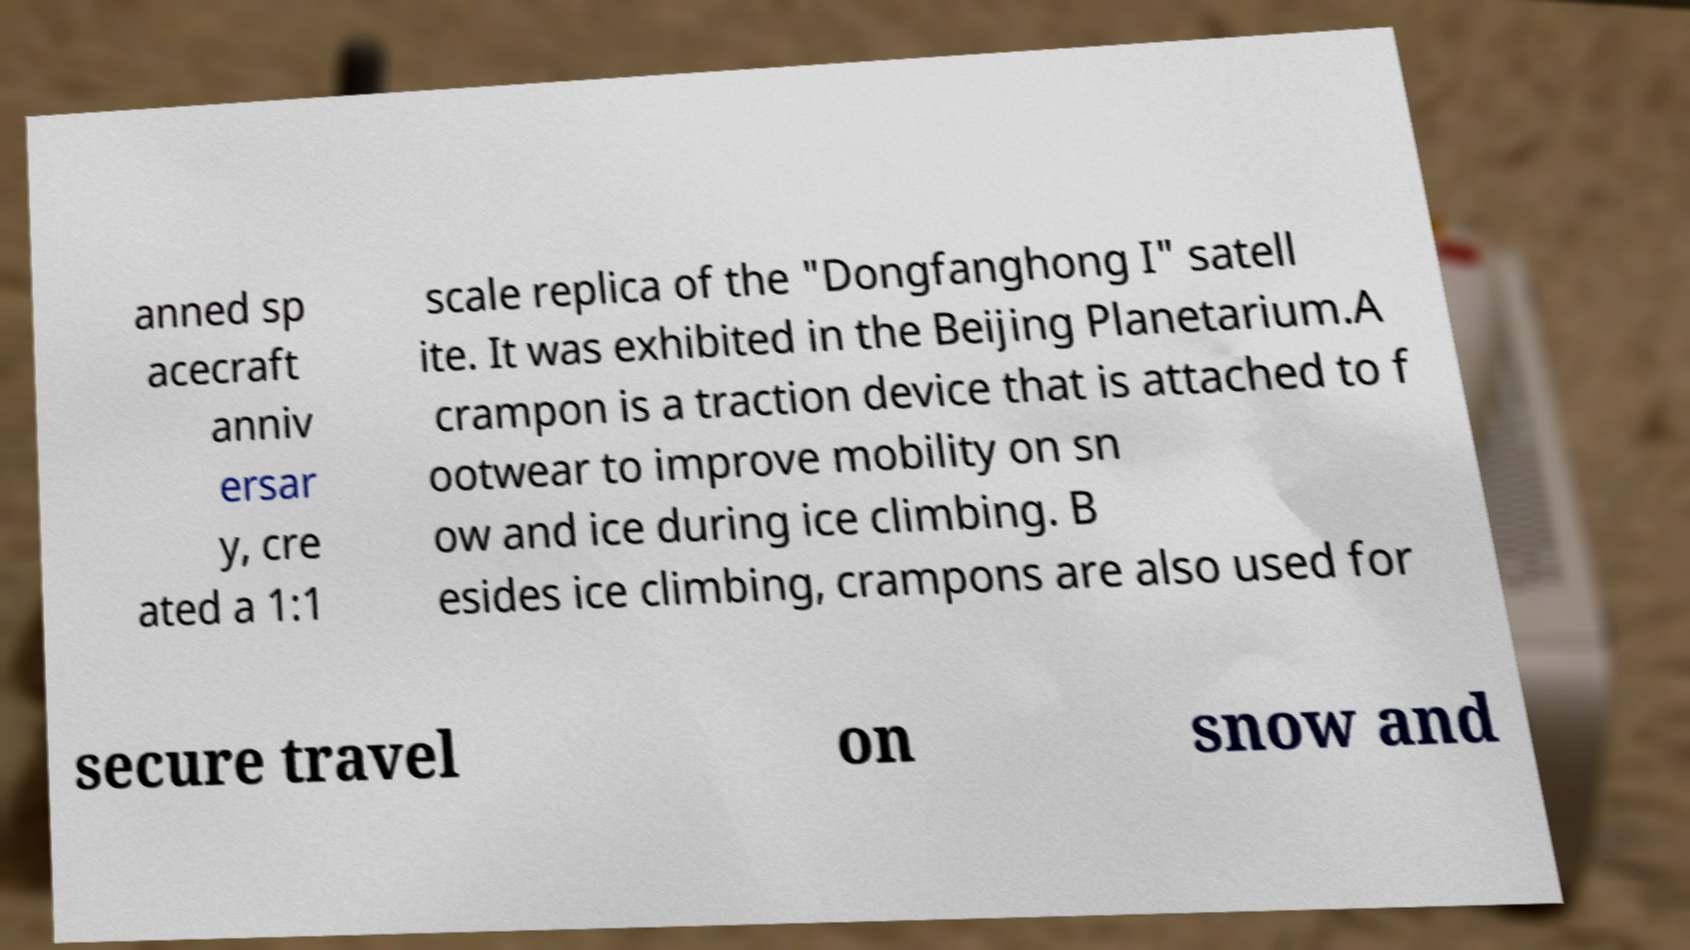Could you assist in decoding the text presented in this image and type it out clearly? anned sp acecraft anniv ersar y, cre ated a 1:1 scale replica of the "Dongfanghong I" satell ite. It was exhibited in the Beijing Planetarium.A crampon is a traction device that is attached to f ootwear to improve mobility on sn ow and ice during ice climbing. B esides ice climbing, crampons are also used for secure travel on snow and 